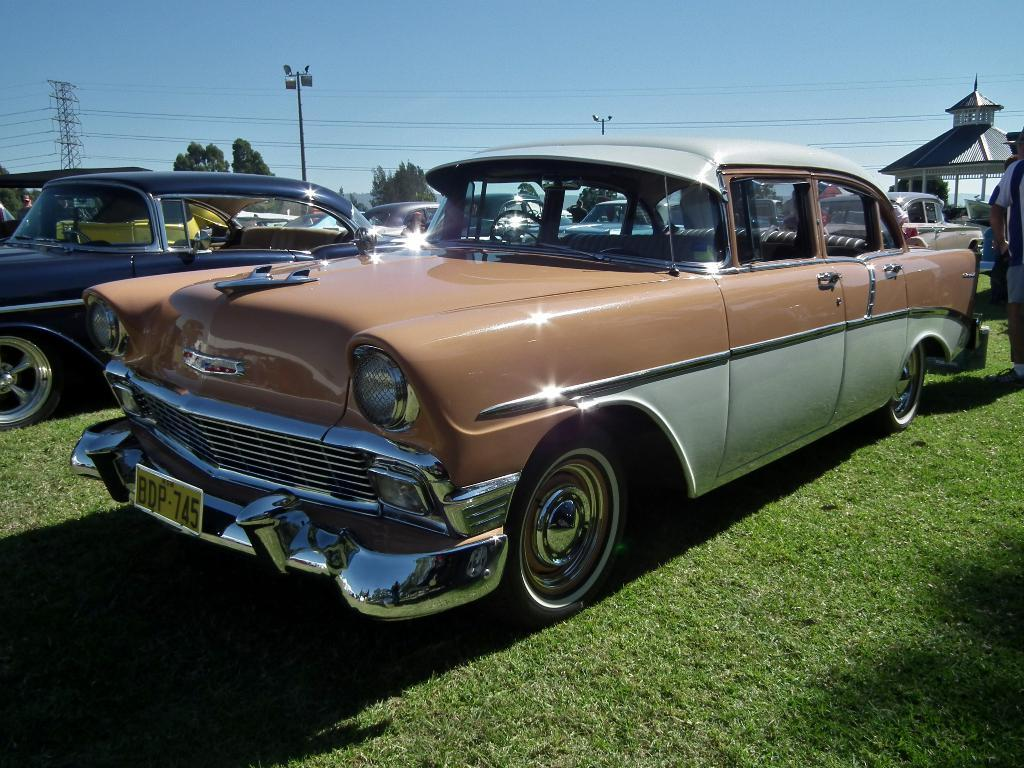What types of vehicles are in the image? There are vehicles in the image, but the specific types are not mentioned. What is the tall structure in the image? There is a tower in the image. What are the wires used for in the image? The purpose of the wires is not mentioned, but they are visible in the image. What are the light poles used for in the image? The light poles are used for providing light, as indicated by their name. What type of building is in the image? There is a house in the image. What are the people doing in the image? There are people in the image, but their actions are not mentioned. What type of vegetation is in the image? There are trees in the image. What is the color of the sky in the image? The sky is blue in color. What type of cart is being used to represent the people in the image? There is no cart present in the image, and the people are not represented by any cart. What is the purpose of rubbing the wires in the image? There is no indication that anyone is rubbing the wires in the image, and their purpose is not mentioned. 